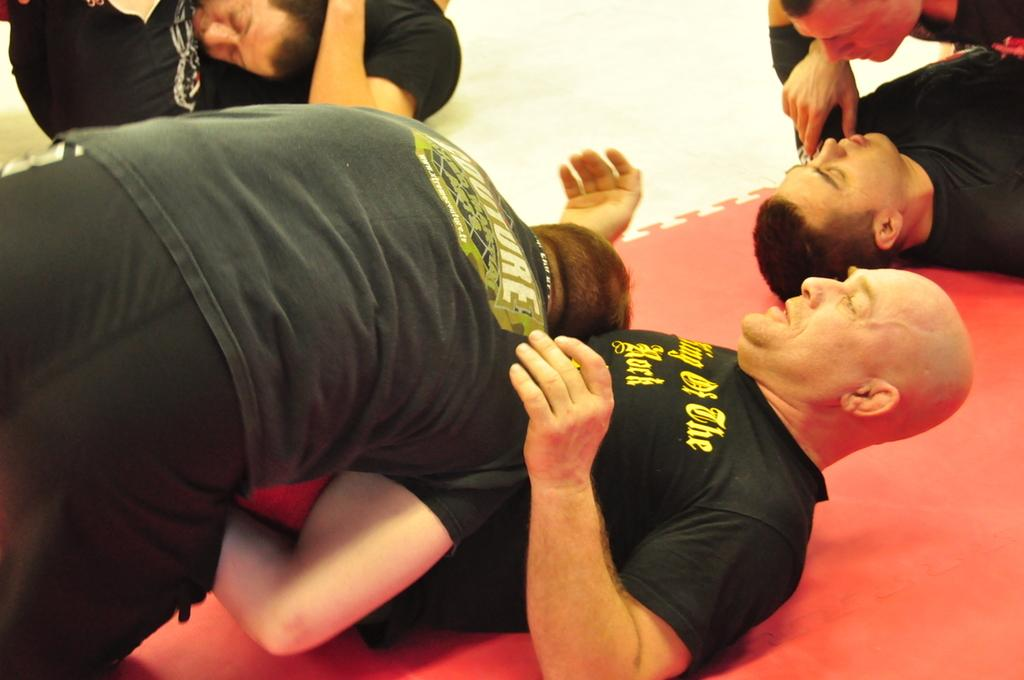How many people are in the image? There is a group of people in the image. What are some of the people in the image doing? Some people are lying on the ground, and some people are on top of others. What type of desk can be seen in the image? There is no desk present in the image. What is the purpose of the gate in the image? There is no gate present in the image. 